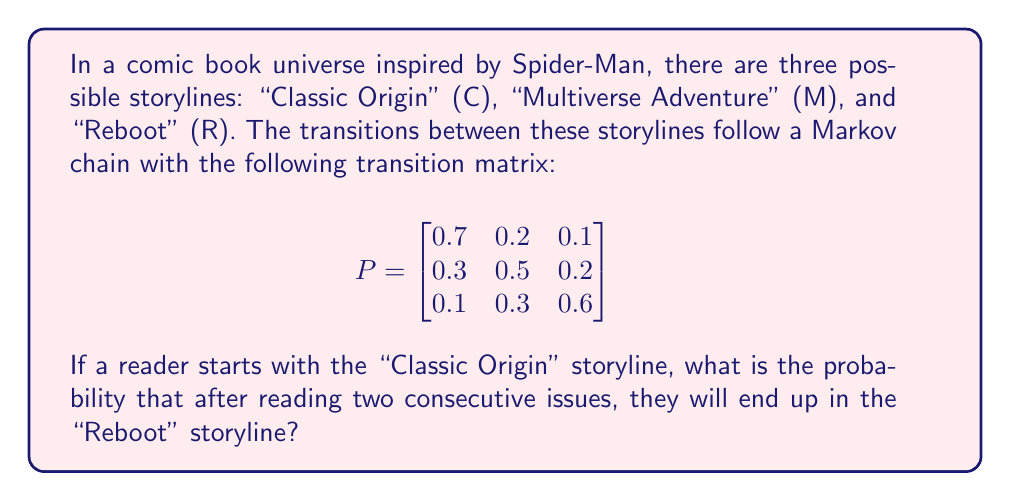Give your solution to this math problem. To solve this problem, we need to use the Markov chain transition matrix and calculate the probability of ending up in the "Reboot" storyline after two transitions, starting from the "Classic Origin" storyline.

Step 1: Identify the starting state vector.
Since we start with the "Classic Origin" storyline, our initial state vector is:
$$v_0 = \begin{bmatrix} 1 & 0 & 0 \end{bmatrix}$$

Step 2: Calculate the state vector after one transition.
$$v_1 = v_0 \cdot P = \begin{bmatrix} 1 & 0 & 0 \end{bmatrix} \cdot \begin{bmatrix}
0.7 & 0.2 & 0.1 \\
0.3 & 0.5 & 0.2 \\
0.1 & 0.3 & 0.6
\end{bmatrix} = \begin{bmatrix} 0.7 & 0.2 & 0.1 \end{bmatrix}$$

Step 3: Calculate the state vector after two transitions.
$$v_2 = v_1 \cdot P = \begin{bmatrix} 0.7 & 0.2 & 0.1 \end{bmatrix} \cdot \begin{bmatrix}
0.7 & 0.2 & 0.1 \\
0.3 & 0.5 & 0.2 \\
0.1 & 0.3 & 0.6
\end{bmatrix}$$

Step 4: Perform the matrix multiplication.
$$v_2 = \begin{bmatrix} (0.7 \cdot 0.7 + 0.2 \cdot 0.3 + 0.1 \cdot 0.1) & (0.7 \cdot 0.2 + 0.2 \cdot 0.5 + 0.1 \cdot 0.3) & (0.7 \cdot 0.1 + 0.2 \cdot 0.2 + 0.1 \cdot 0.6) \end{bmatrix}$$

$$v_2 = \begin{bmatrix} 0.56 & 0.24 & 0.20 \end{bmatrix}$$

Step 5: Identify the probability of ending up in the "Reboot" storyline.
The "Reboot" storyline corresponds to the third element in the state vector, which is 0.20 or 20%.
Answer: 0.20 